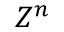Convert formula to latex. <formula><loc_0><loc_0><loc_500><loc_500>Z ^ { n }</formula> 